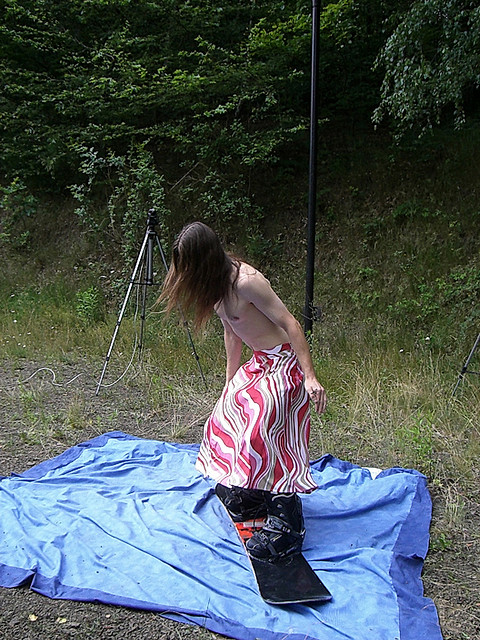<image>What is the pole in the background? I don't know for sure, the pole in the background can be interpreted as a 'light pole', 'camera tripod', 'umbrella stand' or 'flag pole'. What is the pole in the background? I don't know what the pole in the background is. It can be a light pole, a camera tripod, or an umbrella. 